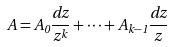Convert formula to latex. <formula><loc_0><loc_0><loc_500><loc_500>A = A _ { 0 } \frac { d z } { z ^ { k } } + \cdots + A _ { k - 1 } \frac { d z } { z }</formula> 